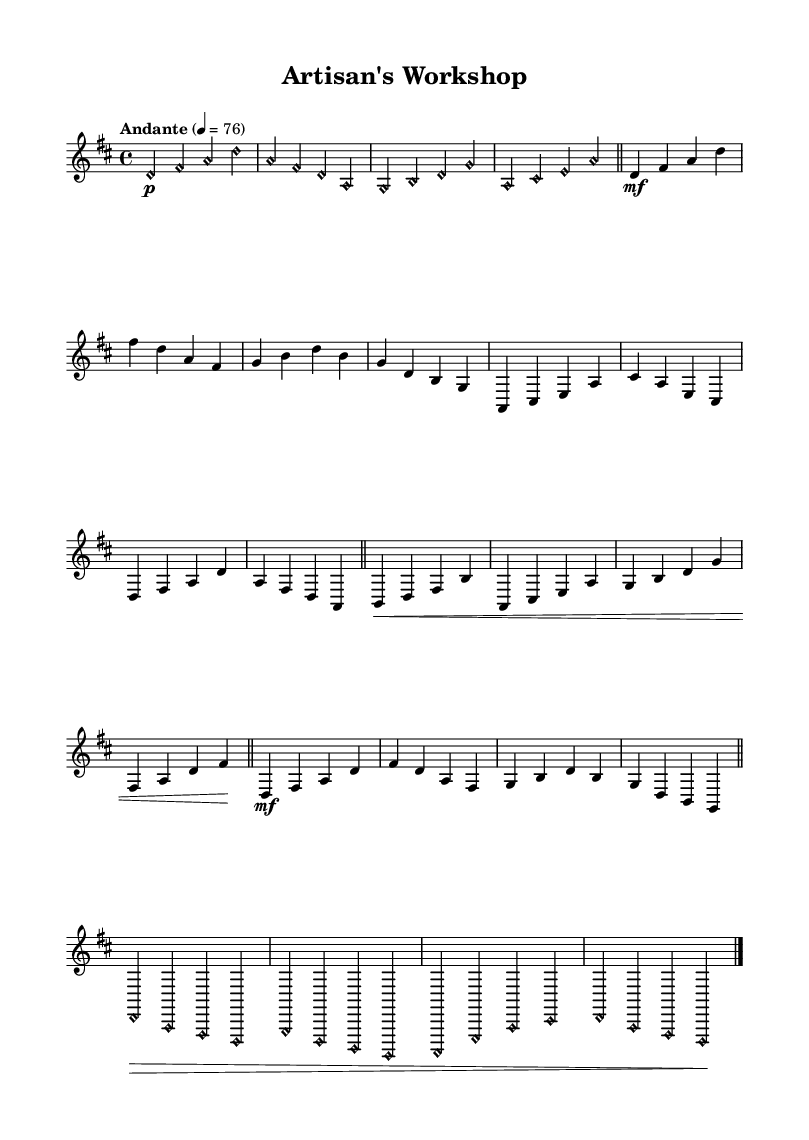What is the key signature of this music? The key signature shows two sharps, which corresponds to the D major scale.
Answer: D major What is the time signature of this piece? The time signature indicated at the beginning of the score is 4/4, meaning there are four beats in each measure and the quarter note gets one beat.
Answer: 4/4 What is the tempo marking for this piece? The tempo marking indicates "Andante," a moderately slow tempo typically between 76 and 108 beats per minute.
Answer: Andante How many sections are present in this piece? The structure of the music includes an Intro, Verse, Bridge, and Outro, indicating there are four distinctive sections in total.
Answer: Four Which instrument is specified for the performance of this music? The score specifies the "acoustic guitar (nylon)" as the instrument to be used, suited to the music's theme of nature and woodworking.
Answer: Acoustic guitar (nylon) What are the dynamics used in the Verse section? In the Verse section, the dynamics start with a forte marking, followed by a variety of accents and a final piano marking at the Outro.
Answer: mf What woodwork-inspired term is used in the piece? The term "harmonic" is used multiple times, suggesting an emphasis on natural harmonics which can reflect the angelic sounds often associated with nature and woodworking craftsmanship.
Answer: Harmonic 